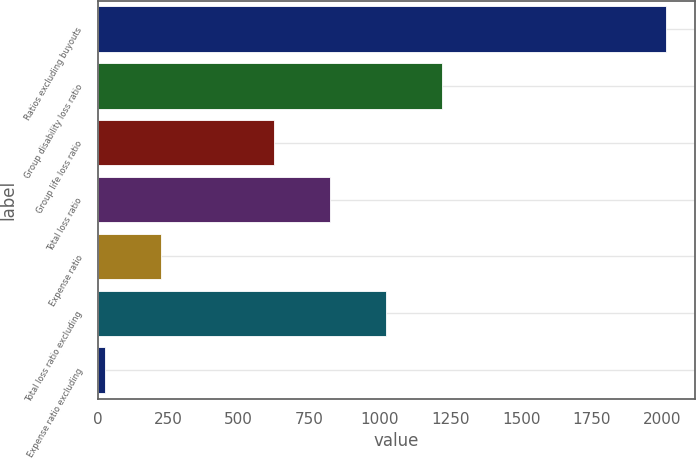<chart> <loc_0><loc_0><loc_500><loc_500><bar_chart><fcel>Ratios excluding buyouts<fcel>Group disability loss ratio<fcel>Group life loss ratio<fcel>Total loss ratio<fcel>Expense ratio<fcel>Total loss ratio excluding<fcel>Expense ratio excluding<nl><fcel>2014<fcel>1219.28<fcel>623.24<fcel>821.92<fcel>225.88<fcel>1020.6<fcel>27.2<nl></chart> 